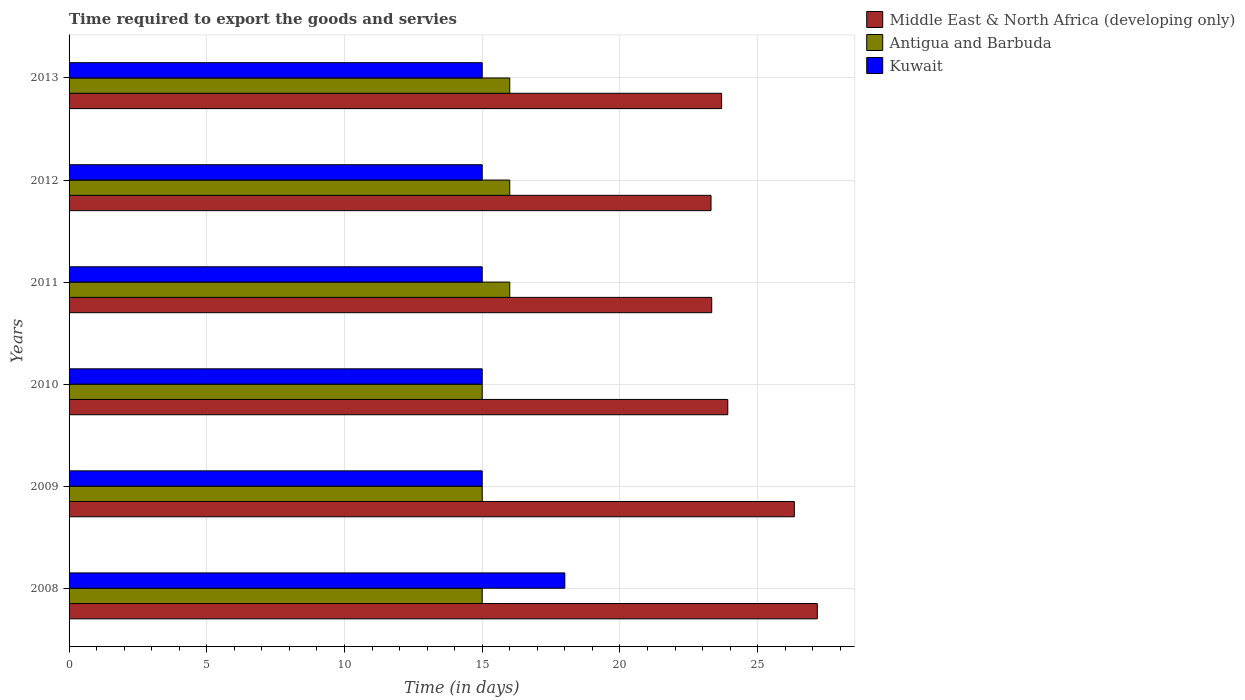Are the number of bars on each tick of the Y-axis equal?
Your response must be concise. Yes. What is the label of the 2nd group of bars from the top?
Your answer should be compact. 2012. In how many cases, is the number of bars for a given year not equal to the number of legend labels?
Ensure brevity in your answer.  0. What is the number of days required to export the goods and services in Antigua and Barbuda in 2009?
Give a very brief answer. 15. Across all years, what is the maximum number of days required to export the goods and services in Middle East & North Africa (developing only)?
Make the answer very short. 27.17. Across all years, what is the minimum number of days required to export the goods and services in Middle East & North Africa (developing only)?
Your answer should be compact. 23.31. In which year was the number of days required to export the goods and services in Middle East & North Africa (developing only) maximum?
Give a very brief answer. 2008. In which year was the number of days required to export the goods and services in Middle East & North Africa (developing only) minimum?
Provide a succinct answer. 2012. What is the total number of days required to export the goods and services in Middle East & North Africa (developing only) in the graph?
Provide a short and direct response. 147.75. What is the difference between the number of days required to export the goods and services in Middle East & North Africa (developing only) in 2011 and that in 2013?
Provide a short and direct response. -0.36. What is the difference between the number of days required to export the goods and services in Antigua and Barbuda in 2009 and the number of days required to export the goods and services in Kuwait in 2012?
Give a very brief answer. 0. What is the average number of days required to export the goods and services in Middle East & North Africa (developing only) per year?
Make the answer very short. 24.62. In the year 2010, what is the difference between the number of days required to export the goods and services in Middle East & North Africa (developing only) and number of days required to export the goods and services in Antigua and Barbuda?
Your response must be concise. 8.92. What is the ratio of the number of days required to export the goods and services in Middle East & North Africa (developing only) in 2009 to that in 2012?
Keep it short and to the point. 1.13. Is the difference between the number of days required to export the goods and services in Middle East & North Africa (developing only) in 2010 and 2013 greater than the difference between the number of days required to export the goods and services in Antigua and Barbuda in 2010 and 2013?
Your answer should be compact. Yes. What is the difference between the highest and the second highest number of days required to export the goods and services in Kuwait?
Provide a succinct answer. 3. What is the difference between the highest and the lowest number of days required to export the goods and services in Antigua and Barbuda?
Your answer should be compact. 1. What does the 3rd bar from the top in 2013 represents?
Keep it short and to the point. Middle East & North Africa (developing only). What does the 3rd bar from the bottom in 2010 represents?
Give a very brief answer. Kuwait. Is it the case that in every year, the sum of the number of days required to export the goods and services in Kuwait and number of days required to export the goods and services in Antigua and Barbuda is greater than the number of days required to export the goods and services in Middle East & North Africa (developing only)?
Your answer should be very brief. Yes. Does the graph contain any zero values?
Offer a terse response. No. Does the graph contain grids?
Your answer should be compact. Yes. What is the title of the graph?
Provide a short and direct response. Time required to export the goods and servies. What is the label or title of the X-axis?
Make the answer very short. Time (in days). What is the Time (in days) in Middle East & North Africa (developing only) in 2008?
Give a very brief answer. 27.17. What is the Time (in days) in Antigua and Barbuda in 2008?
Provide a short and direct response. 15. What is the Time (in days) in Kuwait in 2008?
Ensure brevity in your answer.  18. What is the Time (in days) of Middle East & North Africa (developing only) in 2009?
Offer a very short reply. 26.33. What is the Time (in days) in Antigua and Barbuda in 2009?
Ensure brevity in your answer.  15. What is the Time (in days) in Middle East & North Africa (developing only) in 2010?
Provide a short and direct response. 23.92. What is the Time (in days) of Antigua and Barbuda in 2010?
Your answer should be very brief. 15. What is the Time (in days) in Kuwait in 2010?
Offer a terse response. 15. What is the Time (in days) of Middle East & North Africa (developing only) in 2011?
Keep it short and to the point. 23.33. What is the Time (in days) in Kuwait in 2011?
Make the answer very short. 15. What is the Time (in days) of Middle East & North Africa (developing only) in 2012?
Keep it short and to the point. 23.31. What is the Time (in days) in Middle East & North Africa (developing only) in 2013?
Provide a short and direct response. 23.69. What is the Time (in days) of Antigua and Barbuda in 2013?
Your response must be concise. 16. Across all years, what is the maximum Time (in days) in Middle East & North Africa (developing only)?
Give a very brief answer. 27.17. Across all years, what is the maximum Time (in days) in Antigua and Barbuda?
Give a very brief answer. 16. Across all years, what is the maximum Time (in days) in Kuwait?
Offer a very short reply. 18. Across all years, what is the minimum Time (in days) of Middle East & North Africa (developing only)?
Your answer should be very brief. 23.31. Across all years, what is the minimum Time (in days) in Kuwait?
Provide a succinct answer. 15. What is the total Time (in days) in Middle East & North Africa (developing only) in the graph?
Give a very brief answer. 147.75. What is the total Time (in days) of Antigua and Barbuda in the graph?
Ensure brevity in your answer.  93. What is the total Time (in days) in Kuwait in the graph?
Keep it short and to the point. 93. What is the difference between the Time (in days) of Kuwait in 2008 and that in 2009?
Keep it short and to the point. 3. What is the difference between the Time (in days) of Middle East & North Africa (developing only) in 2008 and that in 2010?
Your response must be concise. 3.25. What is the difference between the Time (in days) in Kuwait in 2008 and that in 2010?
Provide a succinct answer. 3. What is the difference between the Time (in days) in Middle East & North Africa (developing only) in 2008 and that in 2011?
Provide a succinct answer. 3.83. What is the difference between the Time (in days) in Middle East & North Africa (developing only) in 2008 and that in 2012?
Your answer should be very brief. 3.86. What is the difference between the Time (in days) in Antigua and Barbuda in 2008 and that in 2012?
Your answer should be very brief. -1. What is the difference between the Time (in days) in Middle East & North Africa (developing only) in 2008 and that in 2013?
Your answer should be compact. 3.47. What is the difference between the Time (in days) of Antigua and Barbuda in 2008 and that in 2013?
Offer a very short reply. -1. What is the difference between the Time (in days) of Middle East & North Africa (developing only) in 2009 and that in 2010?
Your answer should be very brief. 2.42. What is the difference between the Time (in days) of Antigua and Barbuda in 2009 and that in 2010?
Provide a short and direct response. 0. What is the difference between the Time (in days) of Middle East & North Africa (developing only) in 2009 and that in 2011?
Your answer should be very brief. 3. What is the difference between the Time (in days) in Kuwait in 2009 and that in 2011?
Make the answer very short. 0. What is the difference between the Time (in days) of Middle East & North Africa (developing only) in 2009 and that in 2012?
Your response must be concise. 3.03. What is the difference between the Time (in days) of Antigua and Barbuda in 2009 and that in 2012?
Provide a succinct answer. -1. What is the difference between the Time (in days) of Middle East & North Africa (developing only) in 2009 and that in 2013?
Ensure brevity in your answer.  2.64. What is the difference between the Time (in days) in Middle East & North Africa (developing only) in 2010 and that in 2011?
Offer a very short reply. 0.58. What is the difference between the Time (in days) in Antigua and Barbuda in 2010 and that in 2011?
Your answer should be very brief. -1. What is the difference between the Time (in days) in Kuwait in 2010 and that in 2011?
Offer a terse response. 0. What is the difference between the Time (in days) of Middle East & North Africa (developing only) in 2010 and that in 2012?
Offer a terse response. 0.61. What is the difference between the Time (in days) in Antigua and Barbuda in 2010 and that in 2012?
Provide a short and direct response. -1. What is the difference between the Time (in days) in Middle East & North Africa (developing only) in 2010 and that in 2013?
Your answer should be compact. 0.22. What is the difference between the Time (in days) of Middle East & North Africa (developing only) in 2011 and that in 2012?
Give a very brief answer. 0.03. What is the difference between the Time (in days) of Antigua and Barbuda in 2011 and that in 2012?
Your answer should be compact. 0. What is the difference between the Time (in days) in Kuwait in 2011 and that in 2012?
Make the answer very short. 0. What is the difference between the Time (in days) of Middle East & North Africa (developing only) in 2011 and that in 2013?
Offer a very short reply. -0.36. What is the difference between the Time (in days) in Antigua and Barbuda in 2011 and that in 2013?
Give a very brief answer. 0. What is the difference between the Time (in days) in Kuwait in 2011 and that in 2013?
Your response must be concise. 0. What is the difference between the Time (in days) of Middle East & North Africa (developing only) in 2012 and that in 2013?
Offer a very short reply. -0.38. What is the difference between the Time (in days) of Kuwait in 2012 and that in 2013?
Your answer should be compact. 0. What is the difference between the Time (in days) of Middle East & North Africa (developing only) in 2008 and the Time (in days) of Antigua and Barbuda in 2009?
Your response must be concise. 12.17. What is the difference between the Time (in days) of Middle East & North Africa (developing only) in 2008 and the Time (in days) of Kuwait in 2009?
Keep it short and to the point. 12.17. What is the difference between the Time (in days) of Antigua and Barbuda in 2008 and the Time (in days) of Kuwait in 2009?
Your answer should be very brief. 0. What is the difference between the Time (in days) of Middle East & North Africa (developing only) in 2008 and the Time (in days) of Antigua and Barbuda in 2010?
Your response must be concise. 12.17. What is the difference between the Time (in days) of Middle East & North Africa (developing only) in 2008 and the Time (in days) of Kuwait in 2010?
Your answer should be compact. 12.17. What is the difference between the Time (in days) of Antigua and Barbuda in 2008 and the Time (in days) of Kuwait in 2010?
Your answer should be very brief. 0. What is the difference between the Time (in days) of Middle East & North Africa (developing only) in 2008 and the Time (in days) of Antigua and Barbuda in 2011?
Your answer should be compact. 11.17. What is the difference between the Time (in days) of Middle East & North Africa (developing only) in 2008 and the Time (in days) of Kuwait in 2011?
Your answer should be compact. 12.17. What is the difference between the Time (in days) in Middle East & North Africa (developing only) in 2008 and the Time (in days) in Antigua and Barbuda in 2012?
Make the answer very short. 11.17. What is the difference between the Time (in days) in Middle East & North Africa (developing only) in 2008 and the Time (in days) in Kuwait in 2012?
Ensure brevity in your answer.  12.17. What is the difference between the Time (in days) in Antigua and Barbuda in 2008 and the Time (in days) in Kuwait in 2012?
Make the answer very short. 0. What is the difference between the Time (in days) in Middle East & North Africa (developing only) in 2008 and the Time (in days) in Antigua and Barbuda in 2013?
Make the answer very short. 11.17. What is the difference between the Time (in days) of Middle East & North Africa (developing only) in 2008 and the Time (in days) of Kuwait in 2013?
Ensure brevity in your answer.  12.17. What is the difference between the Time (in days) of Middle East & North Africa (developing only) in 2009 and the Time (in days) of Antigua and Barbuda in 2010?
Give a very brief answer. 11.33. What is the difference between the Time (in days) in Middle East & North Africa (developing only) in 2009 and the Time (in days) in Kuwait in 2010?
Ensure brevity in your answer.  11.33. What is the difference between the Time (in days) of Antigua and Barbuda in 2009 and the Time (in days) of Kuwait in 2010?
Your answer should be compact. 0. What is the difference between the Time (in days) of Middle East & North Africa (developing only) in 2009 and the Time (in days) of Antigua and Barbuda in 2011?
Offer a very short reply. 10.33. What is the difference between the Time (in days) of Middle East & North Africa (developing only) in 2009 and the Time (in days) of Kuwait in 2011?
Offer a terse response. 11.33. What is the difference between the Time (in days) of Middle East & North Africa (developing only) in 2009 and the Time (in days) of Antigua and Barbuda in 2012?
Your answer should be compact. 10.33. What is the difference between the Time (in days) in Middle East & North Africa (developing only) in 2009 and the Time (in days) in Kuwait in 2012?
Your answer should be very brief. 11.33. What is the difference between the Time (in days) in Antigua and Barbuda in 2009 and the Time (in days) in Kuwait in 2012?
Your response must be concise. 0. What is the difference between the Time (in days) of Middle East & North Africa (developing only) in 2009 and the Time (in days) of Antigua and Barbuda in 2013?
Make the answer very short. 10.33. What is the difference between the Time (in days) of Middle East & North Africa (developing only) in 2009 and the Time (in days) of Kuwait in 2013?
Offer a very short reply. 11.33. What is the difference between the Time (in days) in Antigua and Barbuda in 2009 and the Time (in days) in Kuwait in 2013?
Ensure brevity in your answer.  0. What is the difference between the Time (in days) of Middle East & North Africa (developing only) in 2010 and the Time (in days) of Antigua and Barbuda in 2011?
Provide a short and direct response. 7.92. What is the difference between the Time (in days) in Middle East & North Africa (developing only) in 2010 and the Time (in days) in Kuwait in 2011?
Provide a short and direct response. 8.92. What is the difference between the Time (in days) in Middle East & North Africa (developing only) in 2010 and the Time (in days) in Antigua and Barbuda in 2012?
Provide a succinct answer. 7.92. What is the difference between the Time (in days) of Middle East & North Africa (developing only) in 2010 and the Time (in days) of Kuwait in 2012?
Offer a terse response. 8.92. What is the difference between the Time (in days) in Antigua and Barbuda in 2010 and the Time (in days) in Kuwait in 2012?
Ensure brevity in your answer.  0. What is the difference between the Time (in days) of Middle East & North Africa (developing only) in 2010 and the Time (in days) of Antigua and Barbuda in 2013?
Your answer should be compact. 7.92. What is the difference between the Time (in days) in Middle East & North Africa (developing only) in 2010 and the Time (in days) in Kuwait in 2013?
Make the answer very short. 8.92. What is the difference between the Time (in days) in Middle East & North Africa (developing only) in 2011 and the Time (in days) in Antigua and Barbuda in 2012?
Keep it short and to the point. 7.33. What is the difference between the Time (in days) of Middle East & North Africa (developing only) in 2011 and the Time (in days) of Kuwait in 2012?
Provide a short and direct response. 8.33. What is the difference between the Time (in days) in Middle East & North Africa (developing only) in 2011 and the Time (in days) in Antigua and Barbuda in 2013?
Your answer should be compact. 7.33. What is the difference between the Time (in days) of Middle East & North Africa (developing only) in 2011 and the Time (in days) of Kuwait in 2013?
Keep it short and to the point. 8.33. What is the difference between the Time (in days) in Middle East & North Africa (developing only) in 2012 and the Time (in days) in Antigua and Barbuda in 2013?
Your response must be concise. 7.31. What is the difference between the Time (in days) in Middle East & North Africa (developing only) in 2012 and the Time (in days) in Kuwait in 2013?
Provide a succinct answer. 8.31. What is the average Time (in days) of Middle East & North Africa (developing only) per year?
Your response must be concise. 24.62. What is the average Time (in days) of Antigua and Barbuda per year?
Your answer should be compact. 15.5. In the year 2008, what is the difference between the Time (in days) in Middle East & North Africa (developing only) and Time (in days) in Antigua and Barbuda?
Your answer should be very brief. 12.17. In the year 2008, what is the difference between the Time (in days) in Middle East & North Africa (developing only) and Time (in days) in Kuwait?
Your answer should be compact. 9.17. In the year 2009, what is the difference between the Time (in days) of Middle East & North Africa (developing only) and Time (in days) of Antigua and Barbuda?
Your answer should be very brief. 11.33. In the year 2009, what is the difference between the Time (in days) in Middle East & North Africa (developing only) and Time (in days) in Kuwait?
Offer a terse response. 11.33. In the year 2010, what is the difference between the Time (in days) of Middle East & North Africa (developing only) and Time (in days) of Antigua and Barbuda?
Provide a short and direct response. 8.92. In the year 2010, what is the difference between the Time (in days) in Middle East & North Africa (developing only) and Time (in days) in Kuwait?
Your answer should be compact. 8.92. In the year 2011, what is the difference between the Time (in days) of Middle East & North Africa (developing only) and Time (in days) of Antigua and Barbuda?
Make the answer very short. 7.33. In the year 2011, what is the difference between the Time (in days) of Middle East & North Africa (developing only) and Time (in days) of Kuwait?
Make the answer very short. 8.33. In the year 2011, what is the difference between the Time (in days) of Antigua and Barbuda and Time (in days) of Kuwait?
Give a very brief answer. 1. In the year 2012, what is the difference between the Time (in days) of Middle East & North Africa (developing only) and Time (in days) of Antigua and Barbuda?
Your answer should be compact. 7.31. In the year 2012, what is the difference between the Time (in days) of Middle East & North Africa (developing only) and Time (in days) of Kuwait?
Provide a succinct answer. 8.31. In the year 2013, what is the difference between the Time (in days) of Middle East & North Africa (developing only) and Time (in days) of Antigua and Barbuda?
Your response must be concise. 7.69. In the year 2013, what is the difference between the Time (in days) of Middle East & North Africa (developing only) and Time (in days) of Kuwait?
Your answer should be compact. 8.69. In the year 2013, what is the difference between the Time (in days) in Antigua and Barbuda and Time (in days) in Kuwait?
Provide a succinct answer. 1. What is the ratio of the Time (in days) in Middle East & North Africa (developing only) in 2008 to that in 2009?
Make the answer very short. 1.03. What is the ratio of the Time (in days) of Antigua and Barbuda in 2008 to that in 2009?
Offer a very short reply. 1. What is the ratio of the Time (in days) of Middle East & North Africa (developing only) in 2008 to that in 2010?
Your response must be concise. 1.14. What is the ratio of the Time (in days) in Antigua and Barbuda in 2008 to that in 2010?
Keep it short and to the point. 1. What is the ratio of the Time (in days) in Kuwait in 2008 to that in 2010?
Your answer should be very brief. 1.2. What is the ratio of the Time (in days) in Middle East & North Africa (developing only) in 2008 to that in 2011?
Offer a terse response. 1.16. What is the ratio of the Time (in days) of Kuwait in 2008 to that in 2011?
Your answer should be very brief. 1.2. What is the ratio of the Time (in days) of Middle East & North Africa (developing only) in 2008 to that in 2012?
Provide a short and direct response. 1.17. What is the ratio of the Time (in days) in Antigua and Barbuda in 2008 to that in 2012?
Provide a short and direct response. 0.94. What is the ratio of the Time (in days) of Kuwait in 2008 to that in 2012?
Make the answer very short. 1.2. What is the ratio of the Time (in days) of Middle East & North Africa (developing only) in 2008 to that in 2013?
Your response must be concise. 1.15. What is the ratio of the Time (in days) of Antigua and Barbuda in 2008 to that in 2013?
Your answer should be very brief. 0.94. What is the ratio of the Time (in days) of Middle East & North Africa (developing only) in 2009 to that in 2010?
Your response must be concise. 1.1. What is the ratio of the Time (in days) of Antigua and Barbuda in 2009 to that in 2010?
Your answer should be very brief. 1. What is the ratio of the Time (in days) of Middle East & North Africa (developing only) in 2009 to that in 2011?
Make the answer very short. 1.13. What is the ratio of the Time (in days) of Kuwait in 2009 to that in 2011?
Make the answer very short. 1. What is the ratio of the Time (in days) in Middle East & North Africa (developing only) in 2009 to that in 2012?
Make the answer very short. 1.13. What is the ratio of the Time (in days) of Kuwait in 2009 to that in 2012?
Provide a short and direct response. 1. What is the ratio of the Time (in days) in Middle East & North Africa (developing only) in 2009 to that in 2013?
Make the answer very short. 1.11. What is the ratio of the Time (in days) in Kuwait in 2009 to that in 2013?
Ensure brevity in your answer.  1. What is the ratio of the Time (in days) of Antigua and Barbuda in 2010 to that in 2011?
Your response must be concise. 0.94. What is the ratio of the Time (in days) of Middle East & North Africa (developing only) in 2010 to that in 2012?
Provide a short and direct response. 1.03. What is the ratio of the Time (in days) of Kuwait in 2010 to that in 2012?
Your response must be concise. 1. What is the ratio of the Time (in days) of Middle East & North Africa (developing only) in 2010 to that in 2013?
Ensure brevity in your answer.  1.01. What is the ratio of the Time (in days) in Kuwait in 2010 to that in 2013?
Keep it short and to the point. 1. What is the ratio of the Time (in days) of Middle East & North Africa (developing only) in 2011 to that in 2012?
Provide a short and direct response. 1. What is the ratio of the Time (in days) of Antigua and Barbuda in 2011 to that in 2012?
Ensure brevity in your answer.  1. What is the ratio of the Time (in days) in Kuwait in 2011 to that in 2012?
Your response must be concise. 1. What is the ratio of the Time (in days) of Antigua and Barbuda in 2011 to that in 2013?
Your response must be concise. 1. What is the ratio of the Time (in days) in Kuwait in 2011 to that in 2013?
Offer a terse response. 1. What is the ratio of the Time (in days) of Middle East & North Africa (developing only) in 2012 to that in 2013?
Make the answer very short. 0.98. What is the ratio of the Time (in days) in Antigua and Barbuda in 2012 to that in 2013?
Keep it short and to the point. 1. What is the difference between the highest and the second highest Time (in days) of Middle East & North Africa (developing only)?
Ensure brevity in your answer.  0.83. What is the difference between the highest and the second highest Time (in days) in Antigua and Barbuda?
Keep it short and to the point. 0. What is the difference between the highest and the second highest Time (in days) in Kuwait?
Offer a terse response. 3. What is the difference between the highest and the lowest Time (in days) in Middle East & North Africa (developing only)?
Provide a succinct answer. 3.86. What is the difference between the highest and the lowest Time (in days) in Kuwait?
Keep it short and to the point. 3. 